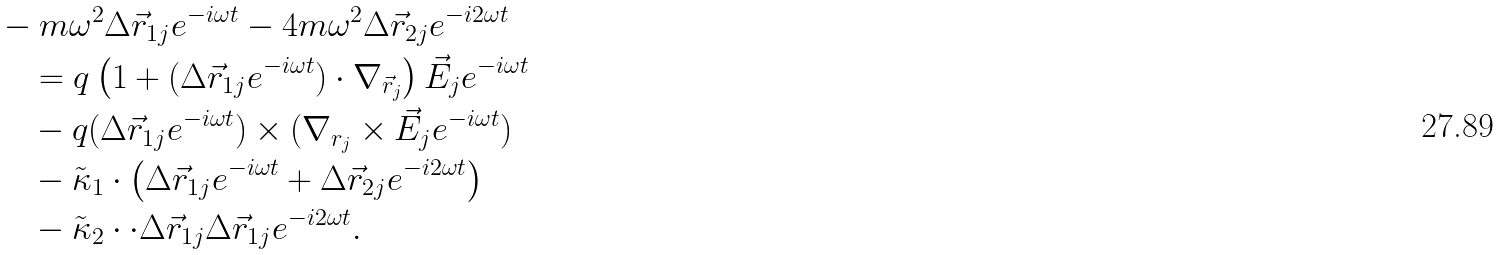<formula> <loc_0><loc_0><loc_500><loc_500>& - m \omega ^ { 2 } \Delta \vec { r } _ { 1 j } e ^ { - i \omega t } - 4 m \omega ^ { 2 } \Delta \vec { r } _ { 2 j } e ^ { - i 2 \omega t } \\ & \quad = q \left ( 1 + ( \Delta \vec { r } _ { 1 j } e ^ { - i \omega t } ) \cdot \nabla _ { \vec { r } _ { j } } \right ) \vec { E } _ { j } e ^ { - i \omega t } \\ & \quad - q ( \Delta \vec { r } _ { 1 j } e ^ { - i \omega t } ) \times ( \nabla _ { r _ { j } } \times \vec { E } _ { j } e ^ { - i \omega t } ) \\ & \quad - \tilde { \kappa } _ { 1 } \cdot \left ( \Delta \vec { r } _ { 1 j } e ^ { - i \omega t } + \Delta \vec { r } _ { 2 j } e ^ { - i 2 \omega t } \right ) \\ & \quad - \tilde { \kappa } _ { 2 } \cdot \cdot \Delta \vec { r } _ { 1 j } \Delta \vec { r } _ { 1 j } e ^ { - i 2 \omega t } .</formula> 